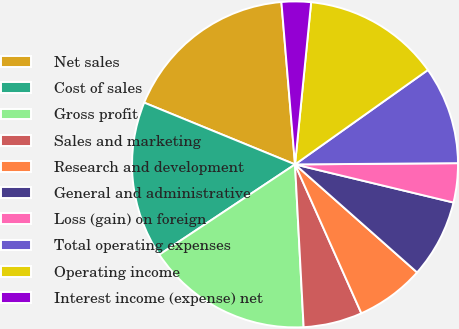<chart> <loc_0><loc_0><loc_500><loc_500><pie_chart><fcel>Net sales<fcel>Cost of sales<fcel>Gross profit<fcel>Sales and marketing<fcel>Research and development<fcel>General and administrative<fcel>Loss (gain) on foreign<fcel>Total operating expenses<fcel>Operating income<fcel>Interest income (expense) net<nl><fcel>17.48%<fcel>15.53%<fcel>16.5%<fcel>5.83%<fcel>6.8%<fcel>7.77%<fcel>3.88%<fcel>9.71%<fcel>13.59%<fcel>2.91%<nl></chart> 